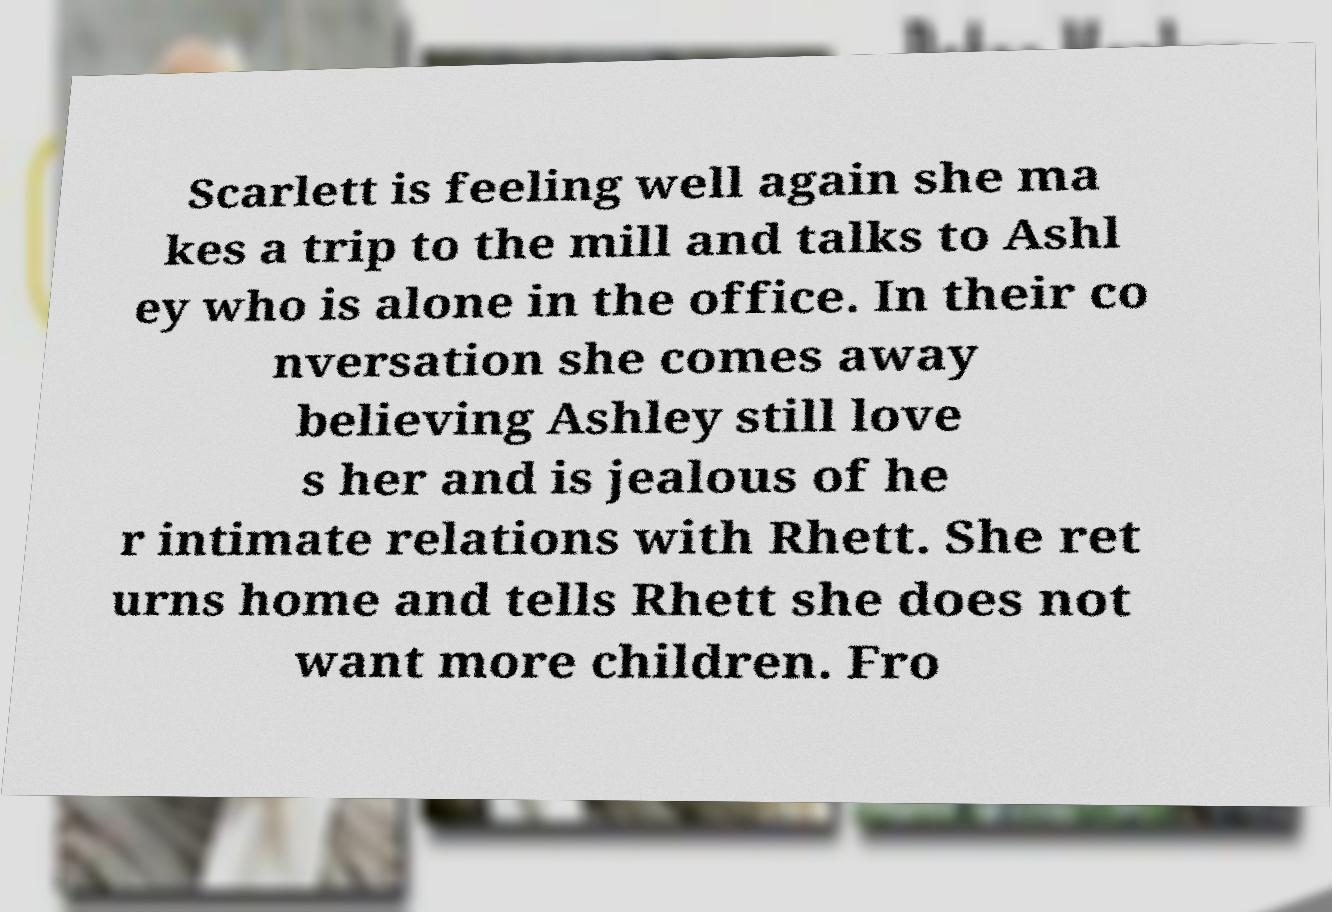For documentation purposes, I need the text within this image transcribed. Could you provide that? Scarlett is feeling well again she ma kes a trip to the mill and talks to Ashl ey who is alone in the office. In their co nversation she comes away believing Ashley still love s her and is jealous of he r intimate relations with Rhett. She ret urns home and tells Rhett she does not want more children. Fro 